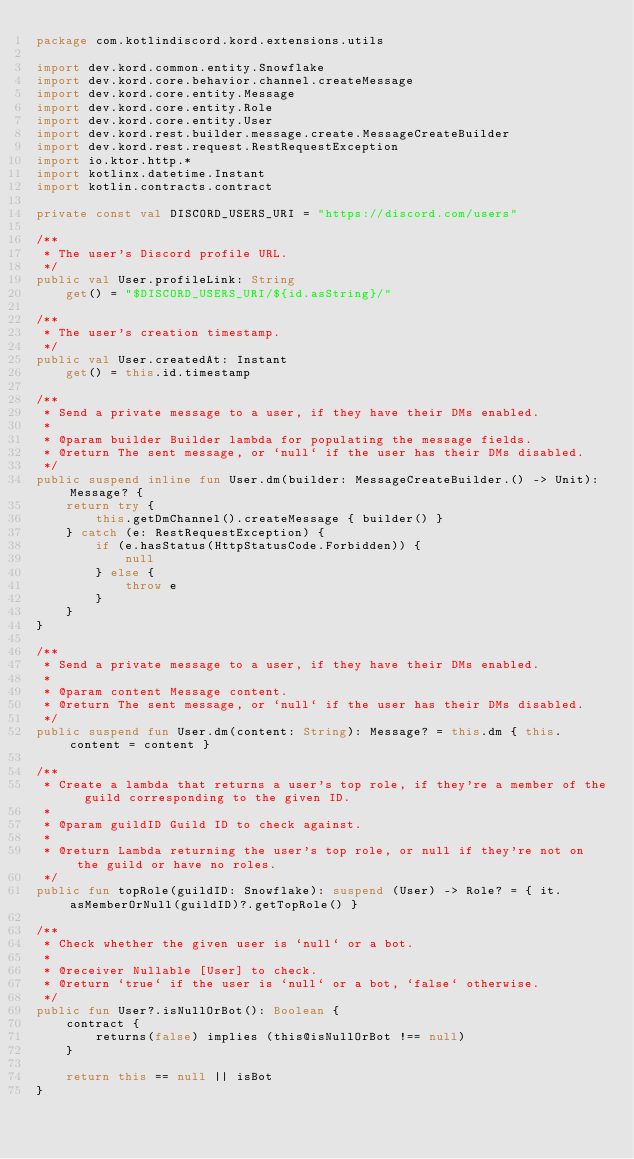Convert code to text. <code><loc_0><loc_0><loc_500><loc_500><_Kotlin_>package com.kotlindiscord.kord.extensions.utils

import dev.kord.common.entity.Snowflake
import dev.kord.core.behavior.channel.createMessage
import dev.kord.core.entity.Message
import dev.kord.core.entity.Role
import dev.kord.core.entity.User
import dev.kord.rest.builder.message.create.MessageCreateBuilder
import dev.kord.rest.request.RestRequestException
import io.ktor.http.*
import kotlinx.datetime.Instant
import kotlin.contracts.contract

private const val DISCORD_USERS_URI = "https://discord.com/users"

/**
 * The user's Discord profile URL.
 */
public val User.profileLink: String
    get() = "$DISCORD_USERS_URI/${id.asString}/"

/**
 * The user's creation timestamp.
 */
public val User.createdAt: Instant
    get() = this.id.timestamp

/**
 * Send a private message to a user, if they have their DMs enabled.
 *
 * @param builder Builder lambda for populating the message fields.
 * @return The sent message, or `null` if the user has their DMs disabled.
 */
public suspend inline fun User.dm(builder: MessageCreateBuilder.() -> Unit): Message? {
    return try {
        this.getDmChannel().createMessage { builder() }
    } catch (e: RestRequestException) {
        if (e.hasStatus(HttpStatusCode.Forbidden)) {
            null
        } else {
            throw e
        }
    }
}

/**
 * Send a private message to a user, if they have their DMs enabled.
 *
 * @param content Message content.
 * @return The sent message, or `null` if the user has their DMs disabled.
 */
public suspend fun User.dm(content: String): Message? = this.dm { this.content = content }

/**
 * Create a lambda that returns a user's top role, if they're a member of the guild corresponding to the given ID.
 *
 * @param guildID Guild ID to check against.
 *
 * @return Lambda returning the user's top role, or null if they're not on the guild or have no roles.
 */
public fun topRole(guildID: Snowflake): suspend (User) -> Role? = { it.asMemberOrNull(guildID)?.getTopRole() }

/**
 * Check whether the given user is `null` or a bot.
 *
 * @receiver Nullable [User] to check.
 * @return `true` if the user is `null` or a bot, `false` otherwise.
 */
public fun User?.isNullOrBot(): Boolean {
    contract {
        returns(false) implies (this@isNullOrBot !== null)
    }

    return this == null || isBot
}
</code> 